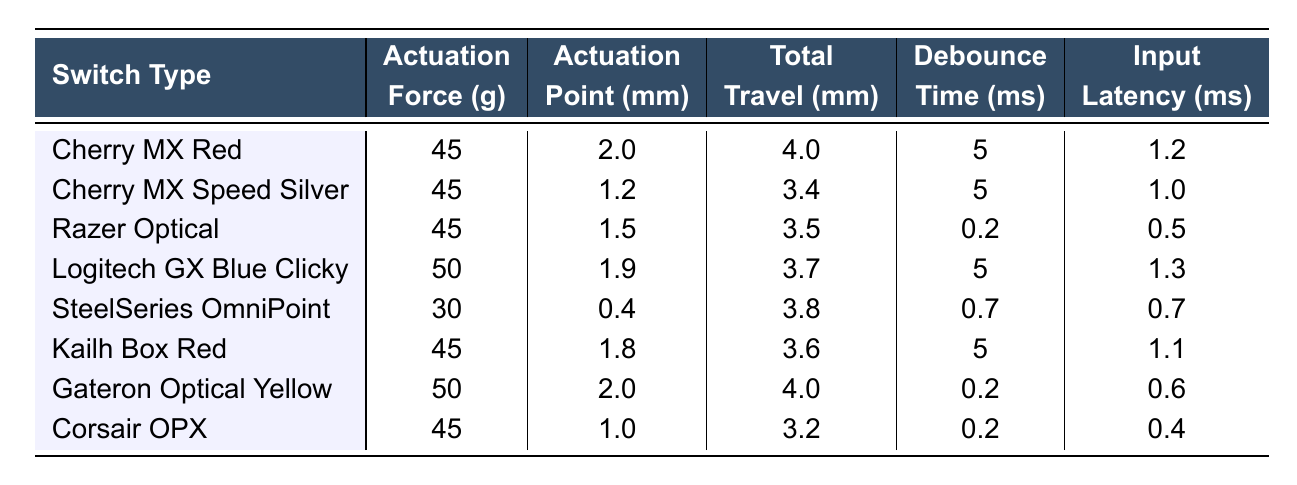What is the input latency of the Razer Optical switch? The table lists the input latency for the Razer Optical switch as 0.5 ms.
Answer: 0.5 ms Which switch type has the highest actuation force? By inspecting the actuation force values, the Logitech GX Blue Clicky switch has the highest at 50 g.
Answer: Logitech GX Blue Clicky What is the average actuation point of all switches? We sum the actuation points: (2.0 + 1.2 + 1.5 + 1.9 + 0.4 + 1.8 + 2.0 + 1.0) = 12.8 mm. There are 8 switches, so the average is 12.8 mm / 8 = 1.6 mm.
Answer: 1.6 mm Is the debounce time of the SteelSeries OmniPoint switch greater than 1 ms? The debounce time for the SteelSeries OmniPoint switch is 0.7 ms, which is not greater than 1 ms.
Answer: No What is the difference in input latency between the fastest and slowest switches? The fastest switch is the Corsair OPX with 0.4 ms, and the slowest is the Logitech GX Blue Clicky with 1.3 ms. The difference is 1.3 ms - 0.4 ms = 0.9 ms.
Answer: 0.9 ms Which switch type has the shortest total travel distance? By comparing the total travel distances, the Corsair OPX has the shortest total travel at 3.2 mm.
Answer: Corsair OPX What percentage of switches have an input latency less than 1 ms? Confirming the switches with input latencies less than 1 ms: Razer Optical (0.5 ms), Gateron Optical Yellow (0.6 ms), and Corsair OPX (0.4 ms) are 3 out of 8. The percentage is (3/8) * 100 = 37.5%.
Answer: 37.5% Are Cherry MX switches generally faster than the SteelSeries OmniPoint switch? Cherry MX Red has an input latency of 1.2 ms and Cherry MX Speed Silver has 1.0 ms. Both are faster than SteelSeries OmniPoint's latency of 0.7 ms (but faster individual Cherry MX models vary). Hence, not all Cherry MX switches are faster than SteelSeries OmniPoint but some are.
Answer: No What is the total actuation force of all switches combined? Adding the actuation forces together: (45 + 45 + 45 + 50 + 30 + 45 + 50 + 45) = 360 g total.
Answer: 360 g Which switch has the highest debounce time? Upon reviewing the debounce times, the Cherry MX Red and Cherry MX Speed Silver both have a debounce time of 5 ms, which is the highest.
Answer: Cherry MX Red / Cherry MX Speed Silver 